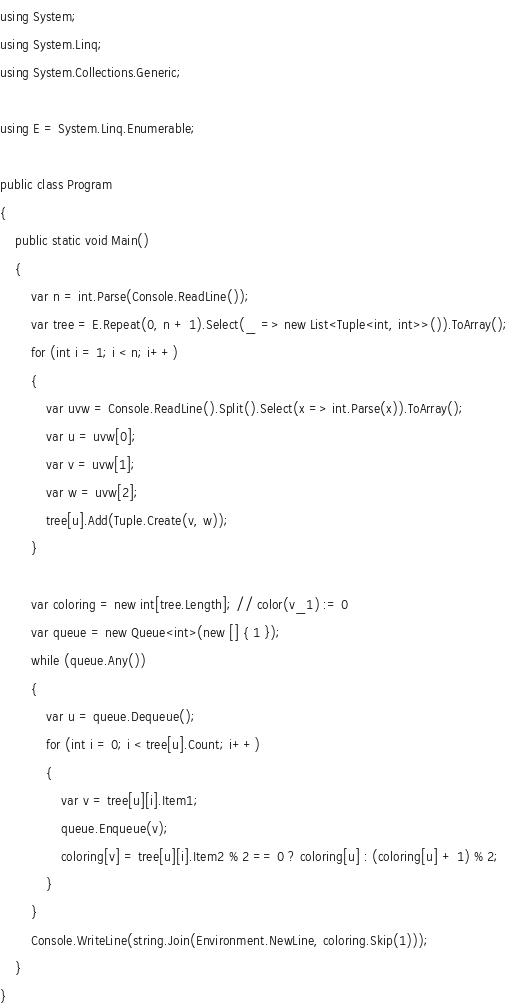<code> <loc_0><loc_0><loc_500><loc_500><_C#_>using System;
using System.Linq;
using System.Collections.Generic;

using E = System.Linq.Enumerable;

public class Program
{
    public static void Main()
    {
        var n = int.Parse(Console.ReadLine());
        var tree = E.Repeat(0, n + 1).Select(_ => new List<Tuple<int, int>>()).ToArray();
        for (int i = 1; i < n; i++)
        {
            var uvw = Console.ReadLine().Split().Select(x => int.Parse(x)).ToArray();
            var u = uvw[0];
            var v = uvw[1];
            var w = uvw[2];
            tree[u].Add(Tuple.Create(v, w));
        }

        var coloring = new int[tree.Length]; // color(v_1) := 0
        var queue = new Queue<int>(new [] { 1 });
        while (queue.Any())
        {
            var u = queue.Dequeue();
            for (int i = 0; i < tree[u].Count; i++)
            {
                var v = tree[u][i].Item1;
                queue.Enqueue(v);
                coloring[v] = tree[u][i].Item2 % 2 == 0 ? coloring[u] : (coloring[u] + 1) % 2;
            }
        }
        Console.WriteLine(string.Join(Environment.NewLine, coloring.Skip(1)));
    }
}
</code> 